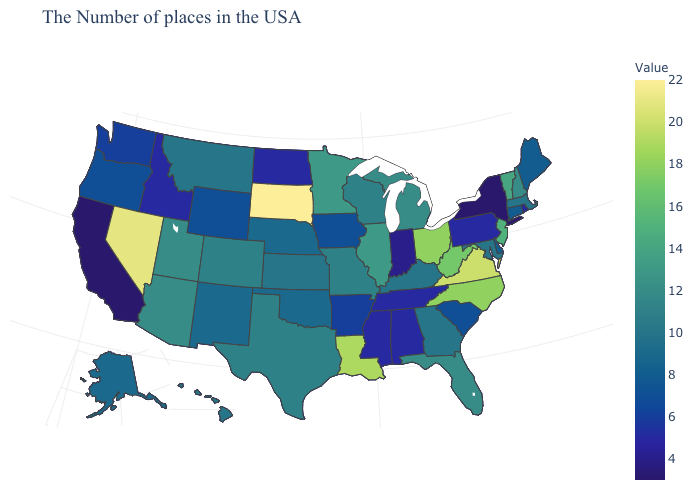Does California have the lowest value in the USA?
Quick response, please. Yes. Which states have the lowest value in the USA?
Write a very short answer. New York, California. Among the states that border Virginia , does Tennessee have the lowest value?
Concise answer only. Yes. Among the states that border Georgia , which have the highest value?
Give a very brief answer. North Carolina. Does Nevada have a higher value than New Jersey?
Keep it brief. Yes. Among the states that border New Mexico , which have the highest value?
Be succinct. Utah, Arizona. 